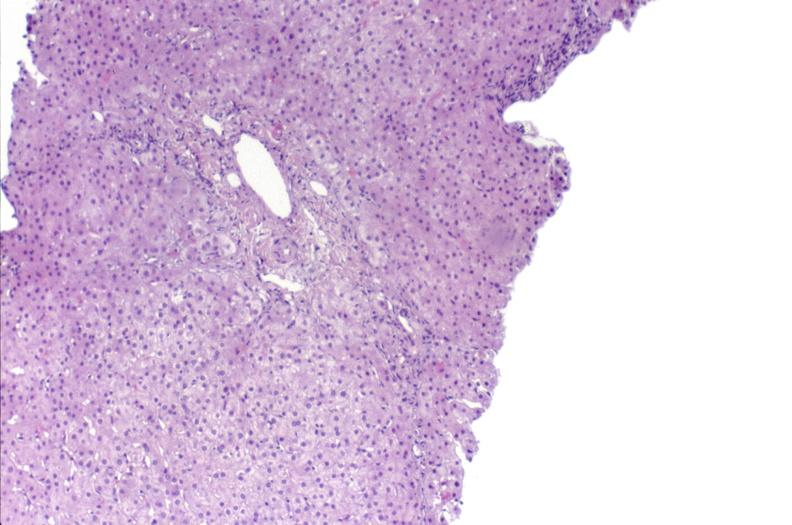what is present?
Answer the question using a single word or phrase. Hepatobiliary 